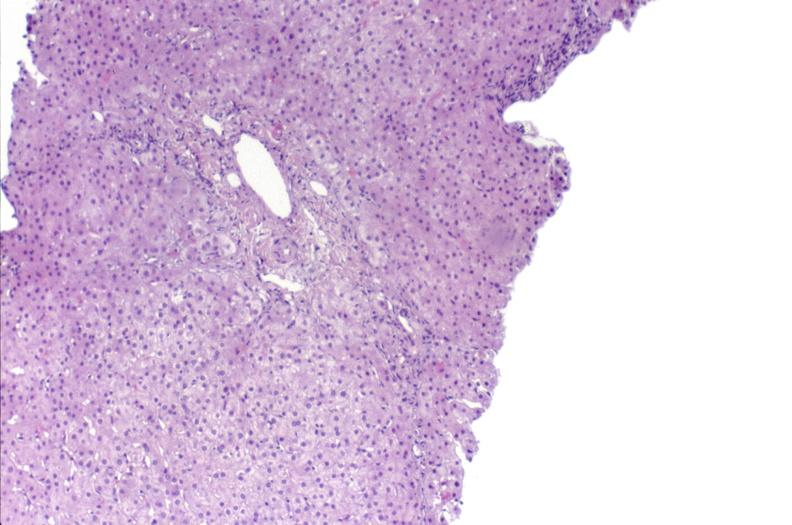what is present?
Answer the question using a single word or phrase. Hepatobiliary 